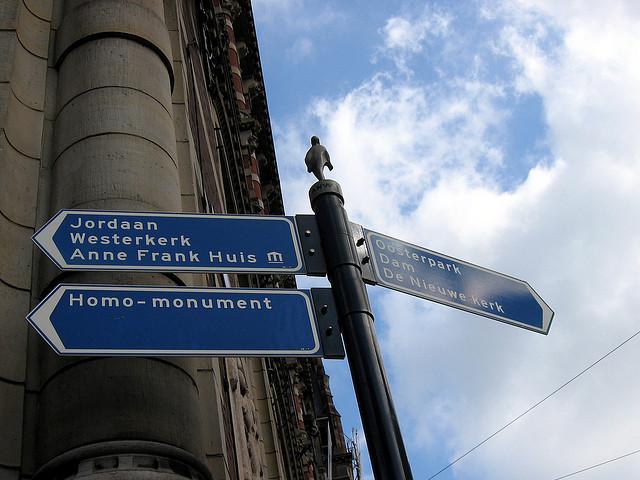What letters are attached to the pole?
Give a very brief answer. Jordaan,westerkerk. Which way is homo-monument?
Write a very short answer. Left. How is the sky?
Be succinct. Cloudy. What is on top of the signpost?
Concise answer only. Bird. Is the sign in English?
Short answer required. No. 